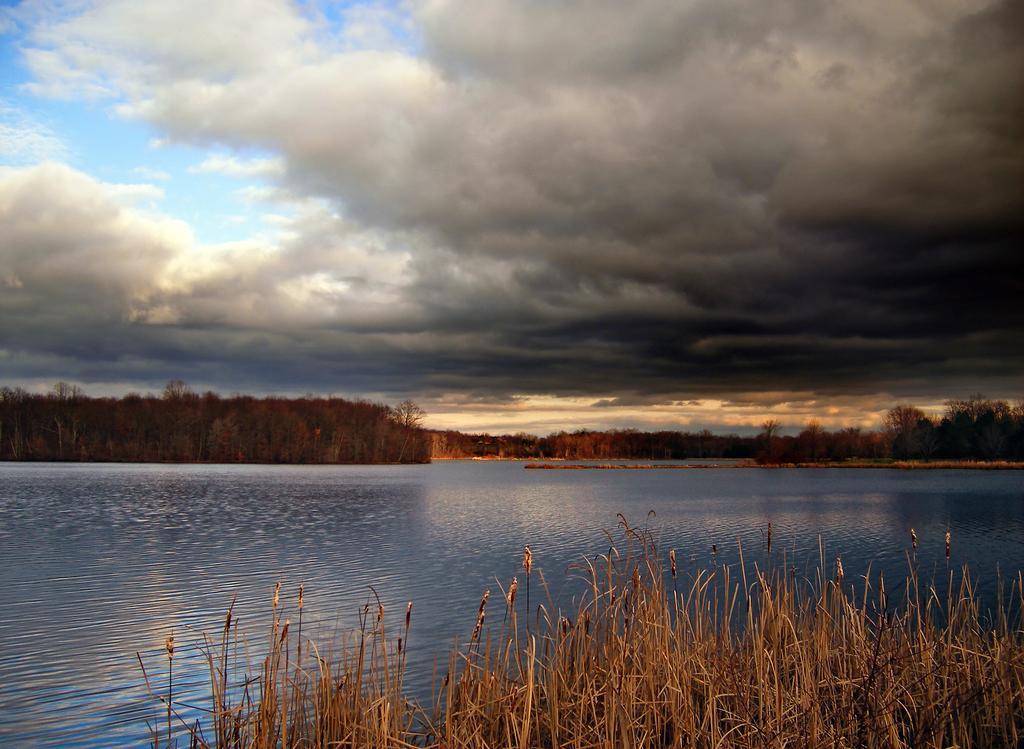How would you summarize this image in a sentence or two? In this image, I can see the water flowing. This is the dried grass. I can see the trees. These are the clouds in the sky. 